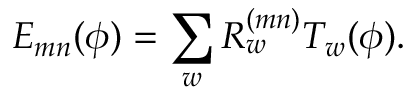<formula> <loc_0><loc_0><loc_500><loc_500>E _ { m n } ( \phi ) = \sum _ { w } R _ { w } ^ { ( m n ) } T _ { w } ( \phi ) .</formula> 